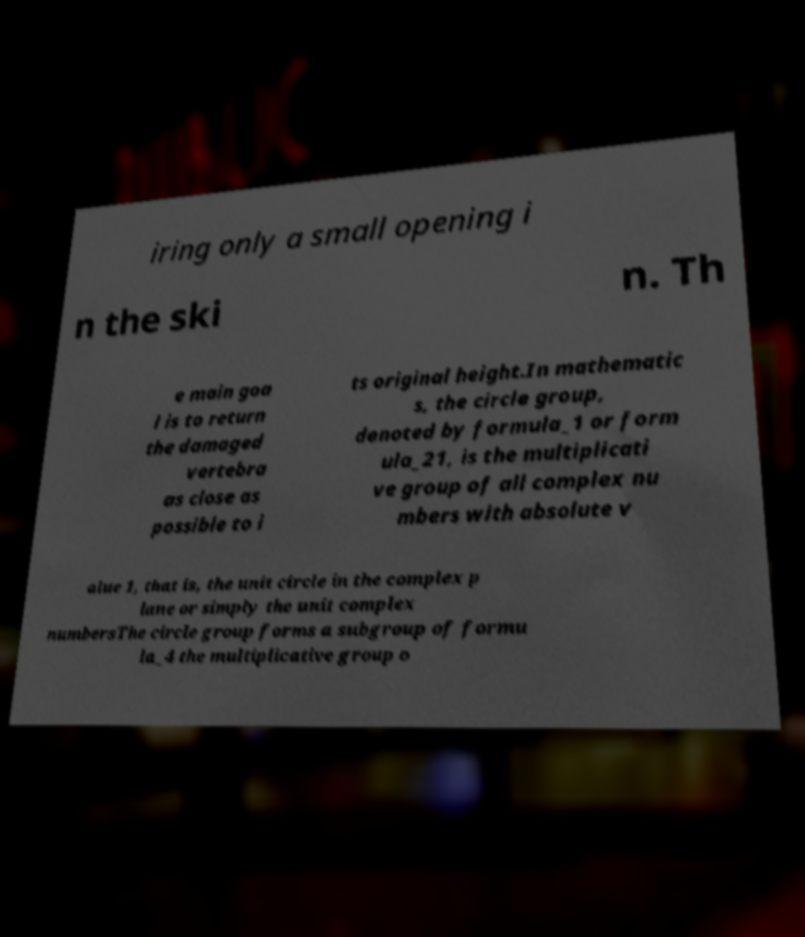Can you accurately transcribe the text from the provided image for me? iring only a small opening i n the ski n. Th e main goa l is to return the damaged vertebra as close as possible to i ts original height.In mathematic s, the circle group, denoted by formula_1 or form ula_21, is the multiplicati ve group of all complex nu mbers with absolute v alue 1, that is, the unit circle in the complex p lane or simply the unit complex numbersThe circle group forms a subgroup of formu la_4 the multiplicative group o 